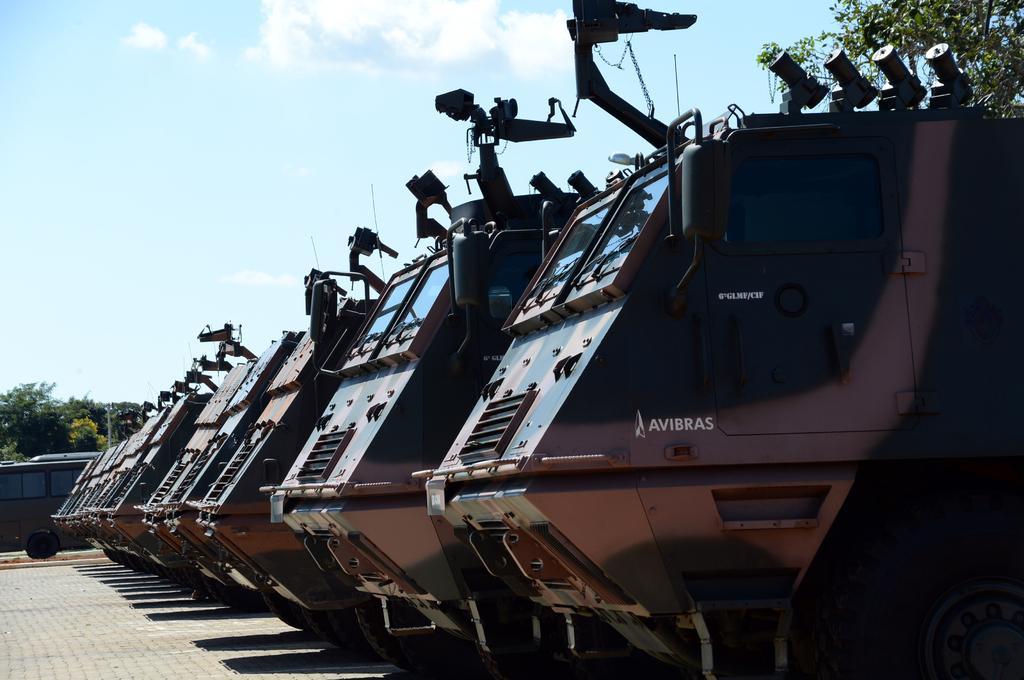Describe this image in one or two sentences. This picture contains six vehicles which are in brown color are parked on the road. Beside that, we see a black van is moving on the road. There are trees in the background. At the top of the picture, we see the sky. It is a sunny day. 